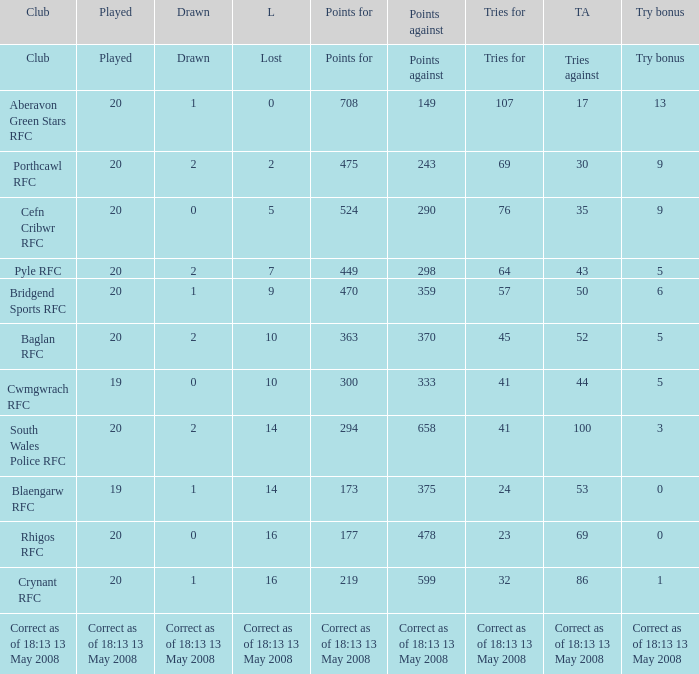What is the points when the try bonus is 1? 219.0. 